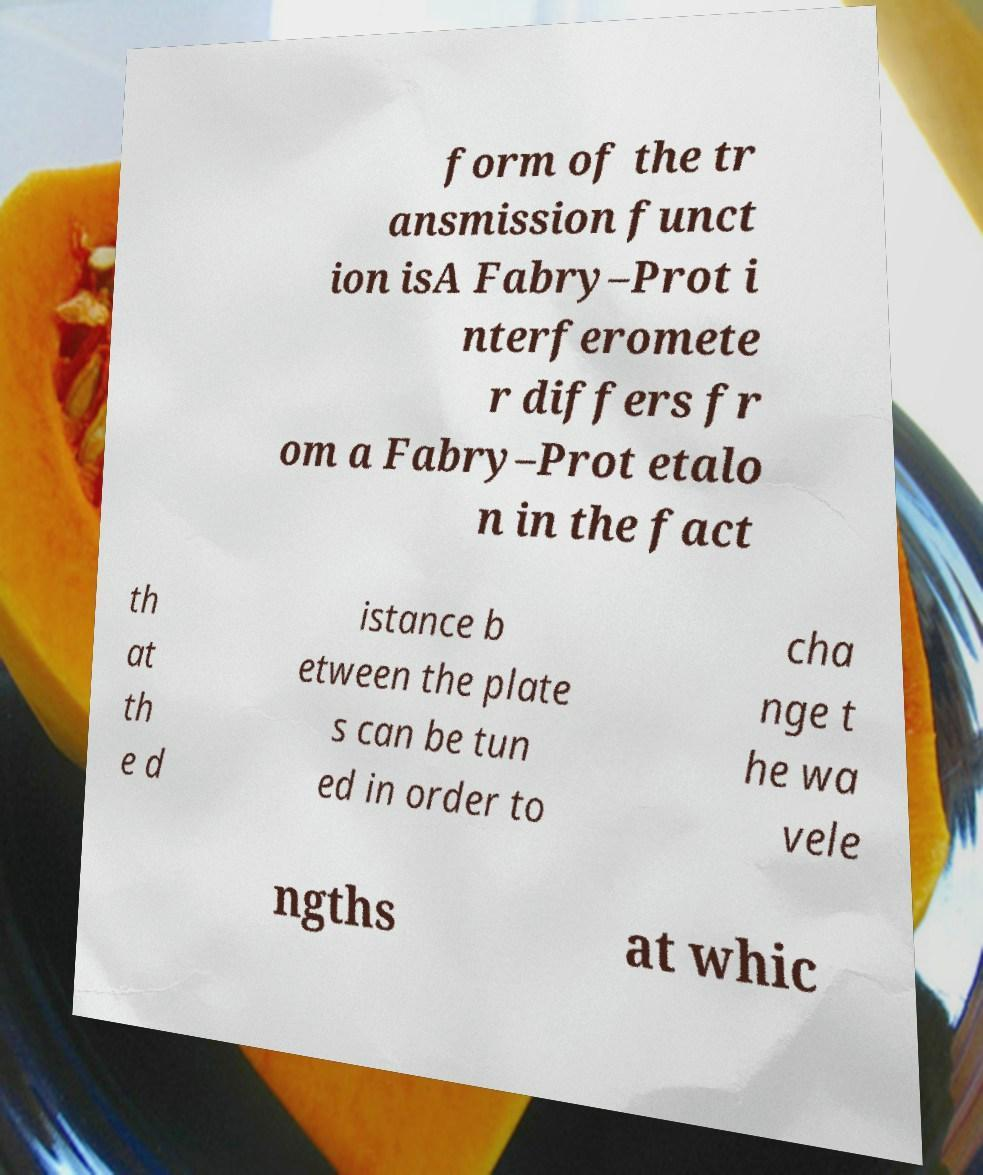Can you accurately transcribe the text from the provided image for me? form of the tr ansmission funct ion isA Fabry–Prot i nterferomete r differs fr om a Fabry–Prot etalo n in the fact th at th e d istance b etween the plate s can be tun ed in order to cha nge t he wa vele ngths at whic 